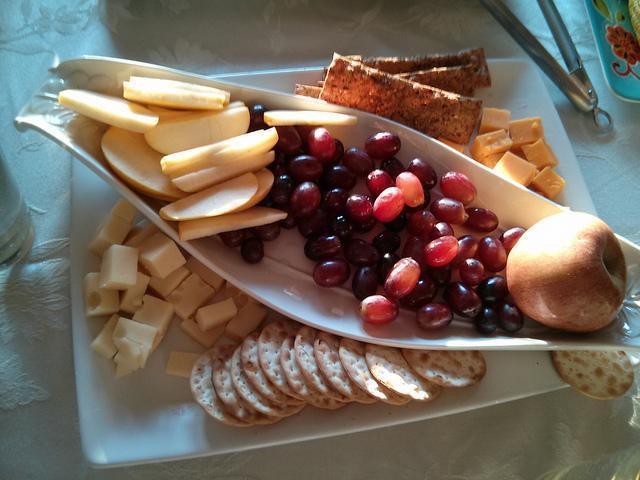How many crackers are shown?
Give a very brief answer. 12. How many apples are there?
Give a very brief answer. 2. 